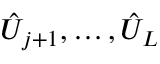<formula> <loc_0><loc_0><loc_500><loc_500>\hat { U } _ { j + 1 } , \dots c , \hat { U } _ { L }</formula> 